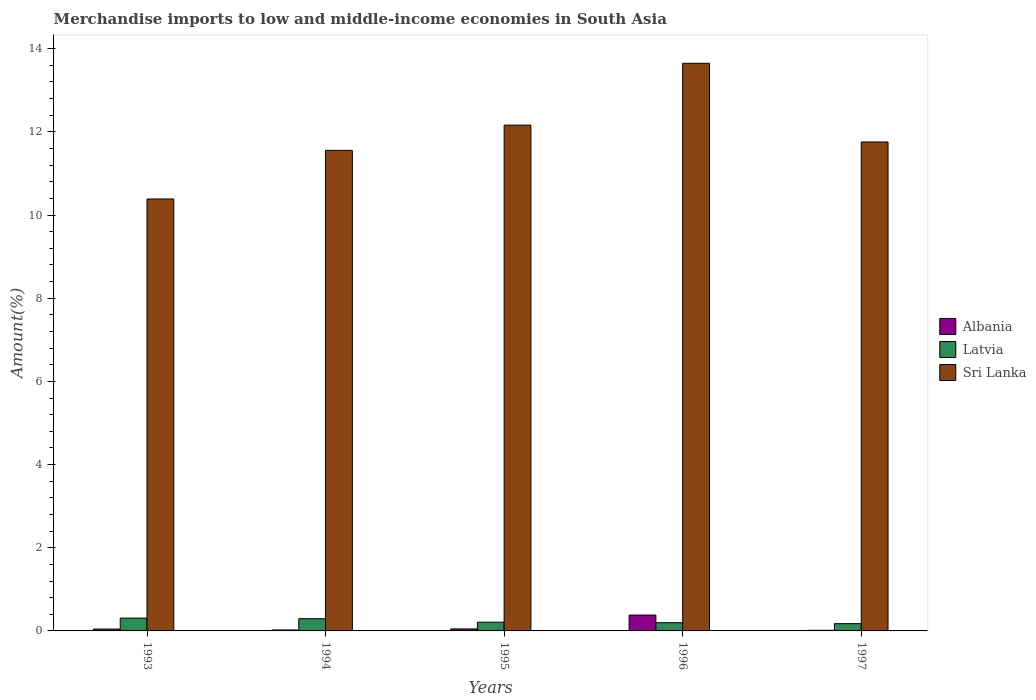Are the number of bars on each tick of the X-axis equal?
Give a very brief answer. Yes. How many bars are there on the 4th tick from the right?
Your answer should be compact. 3. What is the label of the 3rd group of bars from the left?
Give a very brief answer. 1995. What is the percentage of amount earned from merchandise imports in Latvia in 1993?
Offer a terse response. 0.31. Across all years, what is the maximum percentage of amount earned from merchandise imports in Latvia?
Your response must be concise. 0.31. Across all years, what is the minimum percentage of amount earned from merchandise imports in Albania?
Keep it short and to the point. 0.01. What is the total percentage of amount earned from merchandise imports in Albania in the graph?
Make the answer very short. 0.51. What is the difference between the percentage of amount earned from merchandise imports in Latvia in 1993 and that in 1994?
Offer a terse response. 0.01. What is the difference between the percentage of amount earned from merchandise imports in Albania in 1996 and the percentage of amount earned from merchandise imports in Sri Lanka in 1995?
Ensure brevity in your answer.  -11.78. What is the average percentage of amount earned from merchandise imports in Sri Lanka per year?
Offer a very short reply. 11.9. In the year 1997, what is the difference between the percentage of amount earned from merchandise imports in Latvia and percentage of amount earned from merchandise imports in Sri Lanka?
Provide a succinct answer. -11.58. In how many years, is the percentage of amount earned from merchandise imports in Latvia greater than 8 %?
Your answer should be compact. 0. What is the ratio of the percentage of amount earned from merchandise imports in Albania in 1994 to that in 1997?
Your answer should be very brief. 1.54. Is the difference between the percentage of amount earned from merchandise imports in Latvia in 1995 and 1997 greater than the difference between the percentage of amount earned from merchandise imports in Sri Lanka in 1995 and 1997?
Keep it short and to the point. No. What is the difference between the highest and the second highest percentage of amount earned from merchandise imports in Albania?
Your response must be concise. 0.33. What is the difference between the highest and the lowest percentage of amount earned from merchandise imports in Latvia?
Offer a terse response. 0.13. Is the sum of the percentage of amount earned from merchandise imports in Albania in 1994 and 1997 greater than the maximum percentage of amount earned from merchandise imports in Sri Lanka across all years?
Offer a terse response. No. What does the 3rd bar from the left in 1993 represents?
Offer a very short reply. Sri Lanka. What does the 2nd bar from the right in 1997 represents?
Make the answer very short. Latvia. How many years are there in the graph?
Your response must be concise. 5. What is the difference between two consecutive major ticks on the Y-axis?
Your answer should be very brief. 2. Are the values on the major ticks of Y-axis written in scientific E-notation?
Offer a very short reply. No. Does the graph contain any zero values?
Provide a short and direct response. No. Where does the legend appear in the graph?
Your answer should be very brief. Center right. How many legend labels are there?
Offer a terse response. 3. What is the title of the graph?
Your response must be concise. Merchandise imports to low and middle-income economies in South Asia. What is the label or title of the Y-axis?
Your answer should be very brief. Amount(%). What is the Amount(%) of Albania in 1993?
Make the answer very short. 0.04. What is the Amount(%) in Latvia in 1993?
Give a very brief answer. 0.31. What is the Amount(%) in Sri Lanka in 1993?
Your response must be concise. 10.39. What is the Amount(%) in Albania in 1994?
Offer a very short reply. 0.02. What is the Amount(%) of Latvia in 1994?
Your answer should be compact. 0.29. What is the Amount(%) of Sri Lanka in 1994?
Ensure brevity in your answer.  11.55. What is the Amount(%) of Albania in 1995?
Make the answer very short. 0.05. What is the Amount(%) of Latvia in 1995?
Provide a short and direct response. 0.21. What is the Amount(%) of Sri Lanka in 1995?
Make the answer very short. 12.16. What is the Amount(%) of Albania in 1996?
Provide a short and direct response. 0.38. What is the Amount(%) of Latvia in 1996?
Keep it short and to the point. 0.2. What is the Amount(%) in Sri Lanka in 1996?
Offer a terse response. 13.65. What is the Amount(%) in Albania in 1997?
Offer a very short reply. 0.01. What is the Amount(%) in Latvia in 1997?
Your answer should be very brief. 0.17. What is the Amount(%) of Sri Lanka in 1997?
Ensure brevity in your answer.  11.76. Across all years, what is the maximum Amount(%) in Albania?
Your response must be concise. 0.38. Across all years, what is the maximum Amount(%) of Latvia?
Give a very brief answer. 0.31. Across all years, what is the maximum Amount(%) of Sri Lanka?
Ensure brevity in your answer.  13.65. Across all years, what is the minimum Amount(%) in Albania?
Offer a very short reply. 0.01. Across all years, what is the minimum Amount(%) in Latvia?
Provide a short and direct response. 0.17. Across all years, what is the minimum Amount(%) in Sri Lanka?
Make the answer very short. 10.39. What is the total Amount(%) of Albania in the graph?
Offer a terse response. 0.51. What is the total Amount(%) in Latvia in the graph?
Provide a short and direct response. 1.18. What is the total Amount(%) of Sri Lanka in the graph?
Your response must be concise. 59.51. What is the difference between the Amount(%) of Albania in 1993 and that in 1994?
Offer a terse response. 0.02. What is the difference between the Amount(%) of Latvia in 1993 and that in 1994?
Provide a succinct answer. 0.01. What is the difference between the Amount(%) of Sri Lanka in 1993 and that in 1994?
Give a very brief answer. -1.17. What is the difference between the Amount(%) of Albania in 1993 and that in 1995?
Your response must be concise. -0. What is the difference between the Amount(%) of Latvia in 1993 and that in 1995?
Provide a succinct answer. 0.1. What is the difference between the Amount(%) in Sri Lanka in 1993 and that in 1995?
Provide a succinct answer. -1.78. What is the difference between the Amount(%) of Albania in 1993 and that in 1996?
Give a very brief answer. -0.34. What is the difference between the Amount(%) in Latvia in 1993 and that in 1996?
Your answer should be compact. 0.11. What is the difference between the Amount(%) of Sri Lanka in 1993 and that in 1996?
Ensure brevity in your answer.  -3.26. What is the difference between the Amount(%) of Albania in 1993 and that in 1997?
Ensure brevity in your answer.  0.03. What is the difference between the Amount(%) of Latvia in 1993 and that in 1997?
Your answer should be very brief. 0.13. What is the difference between the Amount(%) in Sri Lanka in 1993 and that in 1997?
Provide a succinct answer. -1.37. What is the difference between the Amount(%) of Albania in 1994 and that in 1995?
Give a very brief answer. -0.02. What is the difference between the Amount(%) in Latvia in 1994 and that in 1995?
Provide a succinct answer. 0.08. What is the difference between the Amount(%) of Sri Lanka in 1994 and that in 1995?
Make the answer very short. -0.61. What is the difference between the Amount(%) of Albania in 1994 and that in 1996?
Give a very brief answer. -0.36. What is the difference between the Amount(%) of Latvia in 1994 and that in 1996?
Your response must be concise. 0.1. What is the difference between the Amount(%) of Sri Lanka in 1994 and that in 1996?
Keep it short and to the point. -2.1. What is the difference between the Amount(%) in Albania in 1994 and that in 1997?
Give a very brief answer. 0.01. What is the difference between the Amount(%) in Latvia in 1994 and that in 1997?
Your response must be concise. 0.12. What is the difference between the Amount(%) of Sri Lanka in 1994 and that in 1997?
Give a very brief answer. -0.2. What is the difference between the Amount(%) of Albania in 1995 and that in 1996?
Keep it short and to the point. -0.33. What is the difference between the Amount(%) of Latvia in 1995 and that in 1996?
Offer a very short reply. 0.01. What is the difference between the Amount(%) of Sri Lanka in 1995 and that in 1996?
Provide a succinct answer. -1.49. What is the difference between the Amount(%) of Albania in 1995 and that in 1997?
Your answer should be compact. 0.03. What is the difference between the Amount(%) in Latvia in 1995 and that in 1997?
Your answer should be compact. 0.04. What is the difference between the Amount(%) in Sri Lanka in 1995 and that in 1997?
Make the answer very short. 0.41. What is the difference between the Amount(%) in Albania in 1996 and that in 1997?
Your response must be concise. 0.37. What is the difference between the Amount(%) of Latvia in 1996 and that in 1997?
Ensure brevity in your answer.  0.02. What is the difference between the Amount(%) in Sri Lanka in 1996 and that in 1997?
Your response must be concise. 1.89. What is the difference between the Amount(%) in Albania in 1993 and the Amount(%) in Latvia in 1994?
Offer a very short reply. -0.25. What is the difference between the Amount(%) of Albania in 1993 and the Amount(%) of Sri Lanka in 1994?
Ensure brevity in your answer.  -11.51. What is the difference between the Amount(%) of Latvia in 1993 and the Amount(%) of Sri Lanka in 1994?
Provide a short and direct response. -11.25. What is the difference between the Amount(%) of Albania in 1993 and the Amount(%) of Latvia in 1995?
Your answer should be very brief. -0.17. What is the difference between the Amount(%) in Albania in 1993 and the Amount(%) in Sri Lanka in 1995?
Provide a short and direct response. -12.12. What is the difference between the Amount(%) in Latvia in 1993 and the Amount(%) in Sri Lanka in 1995?
Provide a short and direct response. -11.85. What is the difference between the Amount(%) in Albania in 1993 and the Amount(%) in Latvia in 1996?
Provide a short and direct response. -0.15. What is the difference between the Amount(%) in Albania in 1993 and the Amount(%) in Sri Lanka in 1996?
Keep it short and to the point. -13.61. What is the difference between the Amount(%) in Latvia in 1993 and the Amount(%) in Sri Lanka in 1996?
Offer a very short reply. -13.34. What is the difference between the Amount(%) of Albania in 1993 and the Amount(%) of Latvia in 1997?
Offer a very short reply. -0.13. What is the difference between the Amount(%) of Albania in 1993 and the Amount(%) of Sri Lanka in 1997?
Ensure brevity in your answer.  -11.71. What is the difference between the Amount(%) in Latvia in 1993 and the Amount(%) in Sri Lanka in 1997?
Your answer should be very brief. -11.45. What is the difference between the Amount(%) of Albania in 1994 and the Amount(%) of Latvia in 1995?
Your response must be concise. -0.19. What is the difference between the Amount(%) of Albania in 1994 and the Amount(%) of Sri Lanka in 1995?
Your answer should be very brief. -12.14. What is the difference between the Amount(%) in Latvia in 1994 and the Amount(%) in Sri Lanka in 1995?
Offer a very short reply. -11.87. What is the difference between the Amount(%) of Albania in 1994 and the Amount(%) of Latvia in 1996?
Your response must be concise. -0.17. What is the difference between the Amount(%) of Albania in 1994 and the Amount(%) of Sri Lanka in 1996?
Offer a very short reply. -13.63. What is the difference between the Amount(%) in Latvia in 1994 and the Amount(%) in Sri Lanka in 1996?
Provide a succinct answer. -13.36. What is the difference between the Amount(%) of Albania in 1994 and the Amount(%) of Latvia in 1997?
Your response must be concise. -0.15. What is the difference between the Amount(%) of Albania in 1994 and the Amount(%) of Sri Lanka in 1997?
Ensure brevity in your answer.  -11.73. What is the difference between the Amount(%) of Latvia in 1994 and the Amount(%) of Sri Lanka in 1997?
Offer a very short reply. -11.46. What is the difference between the Amount(%) in Albania in 1995 and the Amount(%) in Latvia in 1996?
Ensure brevity in your answer.  -0.15. What is the difference between the Amount(%) of Albania in 1995 and the Amount(%) of Sri Lanka in 1996?
Your response must be concise. -13.6. What is the difference between the Amount(%) of Latvia in 1995 and the Amount(%) of Sri Lanka in 1996?
Keep it short and to the point. -13.44. What is the difference between the Amount(%) in Albania in 1995 and the Amount(%) in Latvia in 1997?
Your response must be concise. -0.13. What is the difference between the Amount(%) in Albania in 1995 and the Amount(%) in Sri Lanka in 1997?
Ensure brevity in your answer.  -11.71. What is the difference between the Amount(%) of Latvia in 1995 and the Amount(%) of Sri Lanka in 1997?
Ensure brevity in your answer.  -11.55. What is the difference between the Amount(%) in Albania in 1996 and the Amount(%) in Latvia in 1997?
Your answer should be very brief. 0.21. What is the difference between the Amount(%) in Albania in 1996 and the Amount(%) in Sri Lanka in 1997?
Your answer should be very brief. -11.38. What is the difference between the Amount(%) of Latvia in 1996 and the Amount(%) of Sri Lanka in 1997?
Make the answer very short. -11.56. What is the average Amount(%) of Albania per year?
Make the answer very short. 0.1. What is the average Amount(%) of Latvia per year?
Your answer should be compact. 0.24. What is the average Amount(%) of Sri Lanka per year?
Ensure brevity in your answer.  11.9. In the year 1993, what is the difference between the Amount(%) of Albania and Amount(%) of Latvia?
Offer a terse response. -0.26. In the year 1993, what is the difference between the Amount(%) in Albania and Amount(%) in Sri Lanka?
Your answer should be compact. -10.34. In the year 1993, what is the difference between the Amount(%) in Latvia and Amount(%) in Sri Lanka?
Give a very brief answer. -10.08. In the year 1994, what is the difference between the Amount(%) in Albania and Amount(%) in Latvia?
Provide a succinct answer. -0.27. In the year 1994, what is the difference between the Amount(%) of Albania and Amount(%) of Sri Lanka?
Your response must be concise. -11.53. In the year 1994, what is the difference between the Amount(%) of Latvia and Amount(%) of Sri Lanka?
Your response must be concise. -11.26. In the year 1995, what is the difference between the Amount(%) in Albania and Amount(%) in Latvia?
Your answer should be very brief. -0.16. In the year 1995, what is the difference between the Amount(%) in Albania and Amount(%) in Sri Lanka?
Offer a very short reply. -12.11. In the year 1995, what is the difference between the Amount(%) of Latvia and Amount(%) of Sri Lanka?
Your response must be concise. -11.95. In the year 1996, what is the difference between the Amount(%) of Albania and Amount(%) of Latvia?
Make the answer very short. 0.18. In the year 1996, what is the difference between the Amount(%) in Albania and Amount(%) in Sri Lanka?
Provide a succinct answer. -13.27. In the year 1996, what is the difference between the Amount(%) in Latvia and Amount(%) in Sri Lanka?
Keep it short and to the point. -13.45. In the year 1997, what is the difference between the Amount(%) of Albania and Amount(%) of Latvia?
Ensure brevity in your answer.  -0.16. In the year 1997, what is the difference between the Amount(%) in Albania and Amount(%) in Sri Lanka?
Your answer should be very brief. -11.74. In the year 1997, what is the difference between the Amount(%) in Latvia and Amount(%) in Sri Lanka?
Ensure brevity in your answer.  -11.58. What is the ratio of the Amount(%) in Albania in 1993 to that in 1994?
Make the answer very short. 1.93. What is the ratio of the Amount(%) of Latvia in 1993 to that in 1994?
Offer a very short reply. 1.05. What is the ratio of the Amount(%) of Sri Lanka in 1993 to that in 1994?
Provide a succinct answer. 0.9. What is the ratio of the Amount(%) of Albania in 1993 to that in 1995?
Ensure brevity in your answer.  0.93. What is the ratio of the Amount(%) in Latvia in 1993 to that in 1995?
Ensure brevity in your answer.  1.47. What is the ratio of the Amount(%) in Sri Lanka in 1993 to that in 1995?
Ensure brevity in your answer.  0.85. What is the ratio of the Amount(%) in Albania in 1993 to that in 1996?
Keep it short and to the point. 0.12. What is the ratio of the Amount(%) in Latvia in 1993 to that in 1996?
Offer a terse response. 1.56. What is the ratio of the Amount(%) in Sri Lanka in 1993 to that in 1996?
Offer a very short reply. 0.76. What is the ratio of the Amount(%) in Albania in 1993 to that in 1997?
Give a very brief answer. 2.97. What is the ratio of the Amount(%) in Latvia in 1993 to that in 1997?
Offer a very short reply. 1.77. What is the ratio of the Amount(%) in Sri Lanka in 1993 to that in 1997?
Offer a very short reply. 0.88. What is the ratio of the Amount(%) of Albania in 1994 to that in 1995?
Your answer should be compact. 0.48. What is the ratio of the Amount(%) in Latvia in 1994 to that in 1995?
Provide a succinct answer. 1.4. What is the ratio of the Amount(%) of Sri Lanka in 1994 to that in 1995?
Give a very brief answer. 0.95. What is the ratio of the Amount(%) of Albania in 1994 to that in 1996?
Make the answer very short. 0.06. What is the ratio of the Amount(%) in Latvia in 1994 to that in 1996?
Ensure brevity in your answer.  1.49. What is the ratio of the Amount(%) in Sri Lanka in 1994 to that in 1996?
Provide a succinct answer. 0.85. What is the ratio of the Amount(%) in Albania in 1994 to that in 1997?
Your response must be concise. 1.54. What is the ratio of the Amount(%) of Latvia in 1994 to that in 1997?
Make the answer very short. 1.69. What is the ratio of the Amount(%) in Sri Lanka in 1994 to that in 1997?
Keep it short and to the point. 0.98. What is the ratio of the Amount(%) of Albania in 1995 to that in 1996?
Make the answer very short. 0.12. What is the ratio of the Amount(%) in Latvia in 1995 to that in 1996?
Give a very brief answer. 1.06. What is the ratio of the Amount(%) of Sri Lanka in 1995 to that in 1996?
Provide a short and direct response. 0.89. What is the ratio of the Amount(%) in Albania in 1995 to that in 1997?
Ensure brevity in your answer.  3.18. What is the ratio of the Amount(%) of Latvia in 1995 to that in 1997?
Keep it short and to the point. 1.2. What is the ratio of the Amount(%) in Sri Lanka in 1995 to that in 1997?
Your answer should be very brief. 1.03. What is the ratio of the Amount(%) in Albania in 1996 to that in 1997?
Provide a succinct answer. 25.44. What is the ratio of the Amount(%) of Latvia in 1996 to that in 1997?
Provide a succinct answer. 1.14. What is the ratio of the Amount(%) in Sri Lanka in 1996 to that in 1997?
Provide a succinct answer. 1.16. What is the difference between the highest and the second highest Amount(%) in Albania?
Provide a succinct answer. 0.33. What is the difference between the highest and the second highest Amount(%) in Latvia?
Offer a very short reply. 0.01. What is the difference between the highest and the second highest Amount(%) in Sri Lanka?
Provide a short and direct response. 1.49. What is the difference between the highest and the lowest Amount(%) of Albania?
Make the answer very short. 0.37. What is the difference between the highest and the lowest Amount(%) in Latvia?
Give a very brief answer. 0.13. What is the difference between the highest and the lowest Amount(%) of Sri Lanka?
Make the answer very short. 3.26. 